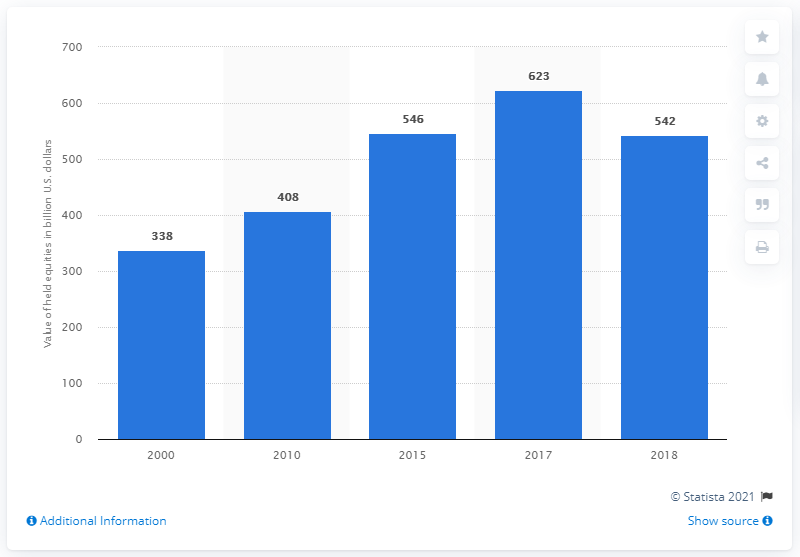Draw attention to some important aspects in this diagram. In 2018, U.S. life insurers held approximately $542 billion in equities. 